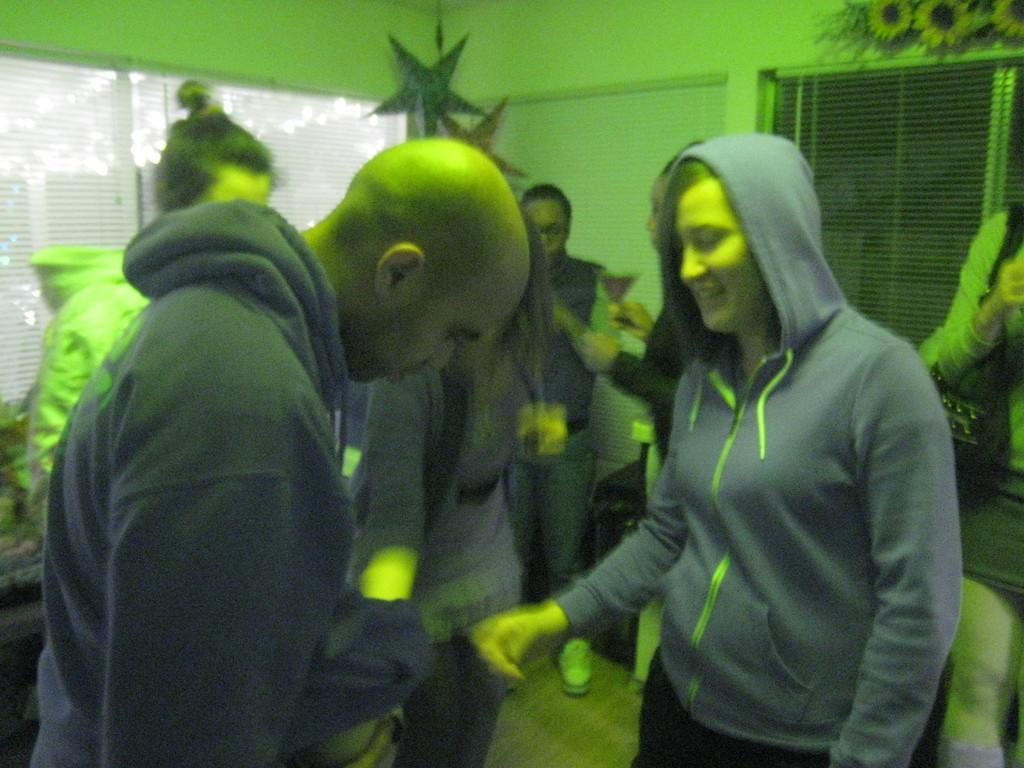Can you describe this image briefly? Inside this room we can see people. These are windows. Here we can see stars and flowers. One person is holding a glass. 